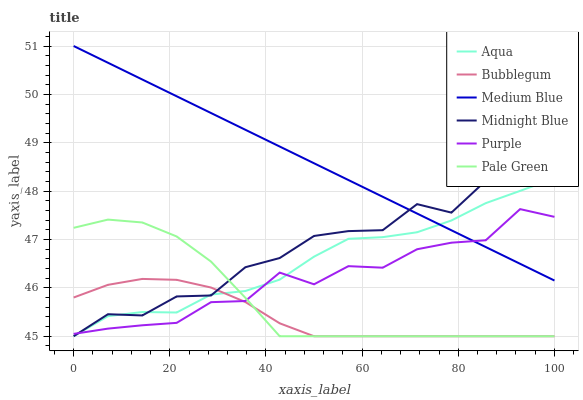Does Bubblegum have the minimum area under the curve?
Answer yes or no. Yes. Does Medium Blue have the maximum area under the curve?
Answer yes or no. Yes. Does Purple have the minimum area under the curve?
Answer yes or no. No. Does Purple have the maximum area under the curve?
Answer yes or no. No. Is Medium Blue the smoothest?
Answer yes or no. Yes. Is Midnight Blue the roughest?
Answer yes or no. Yes. Is Purple the smoothest?
Answer yes or no. No. Is Purple the roughest?
Answer yes or no. No. Does Midnight Blue have the lowest value?
Answer yes or no. Yes. Does Purple have the lowest value?
Answer yes or no. No. Does Medium Blue have the highest value?
Answer yes or no. Yes. Does Purple have the highest value?
Answer yes or no. No. Is Bubblegum less than Medium Blue?
Answer yes or no. Yes. Is Medium Blue greater than Bubblegum?
Answer yes or no. Yes. Does Medium Blue intersect Aqua?
Answer yes or no. Yes. Is Medium Blue less than Aqua?
Answer yes or no. No. Is Medium Blue greater than Aqua?
Answer yes or no. No. Does Bubblegum intersect Medium Blue?
Answer yes or no. No. 